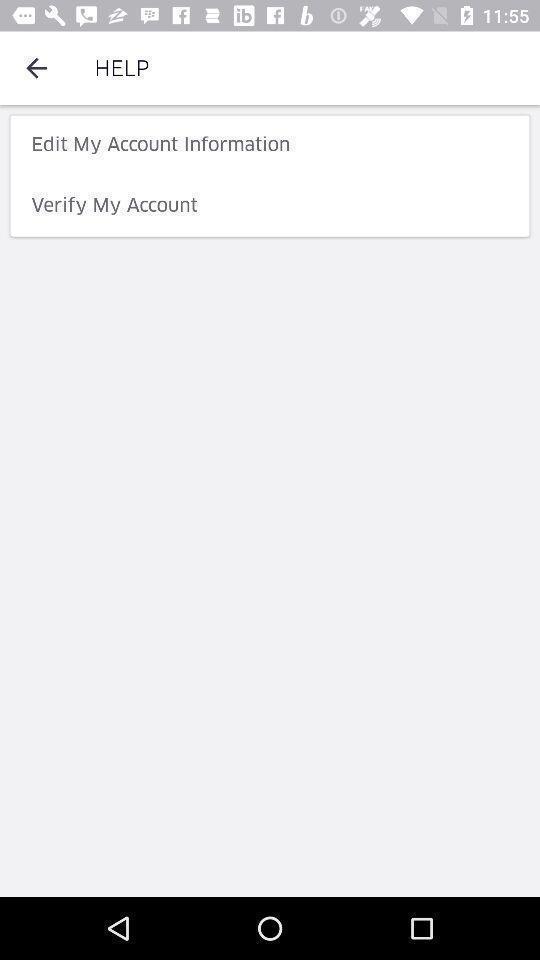Provide a description of this screenshot. Screen displaying the help page. 